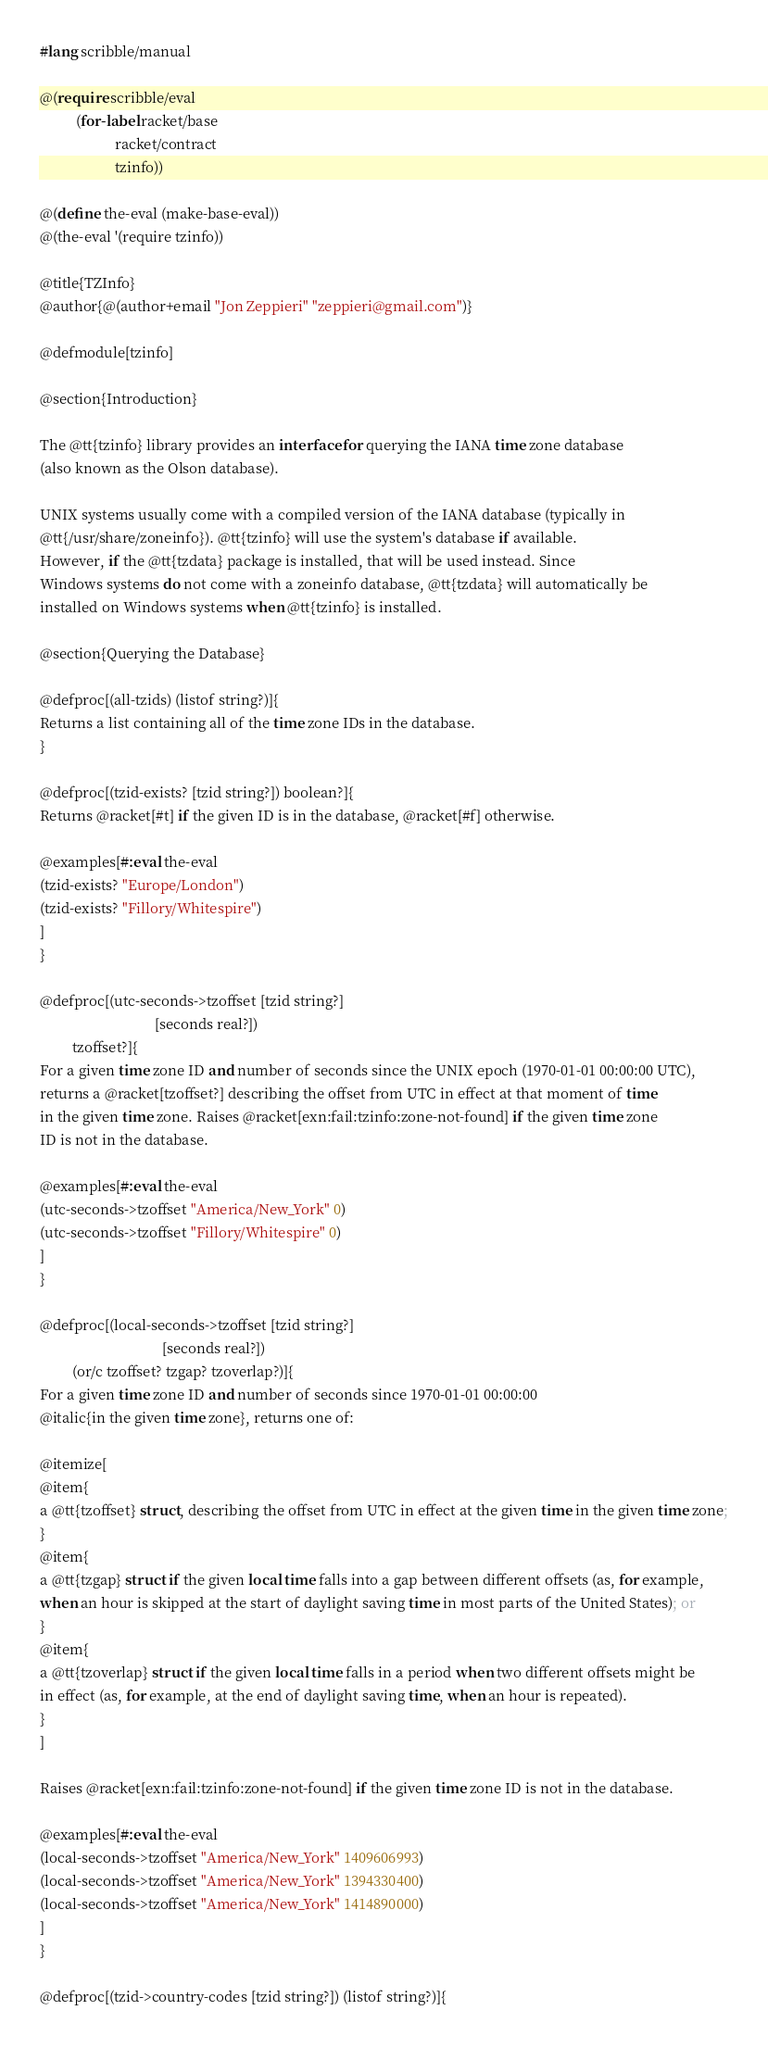<code> <loc_0><loc_0><loc_500><loc_500><_Racket_>#lang scribble/manual

@(require scribble/eval
          (for-label racket/base
                     racket/contract
                     tzinfo))

@(define the-eval (make-base-eval))
@(the-eval '(require tzinfo))

@title{TZInfo}
@author{@(author+email "Jon Zeppieri" "zeppieri@gmail.com")}

@defmodule[tzinfo]

@section{Introduction}

The @tt{tzinfo} library provides an interface for querying the IANA time zone database
(also known as the Olson database).

UNIX systems usually come with a compiled version of the IANA database (typically in
@tt{/usr/share/zoneinfo}). @tt{tzinfo} will use the system's database if available.
However, if the @tt{tzdata} package is installed, that will be used instead. Since
Windows systems do not come with a zoneinfo database, @tt{tzdata} will automatically be
installed on Windows systems when @tt{tzinfo} is installed.

@section{Querying the Database}

@defproc[(all-tzids) (listof string?)]{
Returns a list containing all of the time zone IDs in the database.
}

@defproc[(tzid-exists? [tzid string?]) boolean?]{
Returns @racket[#t] if the given ID is in the database, @racket[#f] otherwise.
        
@examples[#:eval the-eval
(tzid-exists? "Europe/London")
(tzid-exists? "Fillory/Whitespire")
]
}

@defproc[(utc-seconds->tzoffset [tzid string?]
                                [seconds real?])
         tzoffset?]{
For a given time zone ID and number of seconds since the UNIX epoch (1970-01-01 00:00:00 UTC),
returns a @racket[tzoffset?] describing the offset from UTC in effect at that moment of time
in the given time zone. Raises @racket[exn:fail:tzinfo:zone-not-found] if the given time zone
ID is not in the database.

@examples[#:eval the-eval
(utc-seconds->tzoffset "America/New_York" 0)
(utc-seconds->tzoffset "Fillory/Whitespire" 0)
]
}

@defproc[(local-seconds->tzoffset [tzid string?]
                                  [seconds real?])
         (or/c tzoffset? tzgap? tzoverlap?)]{
For a given time zone ID and number of seconds since 1970-01-01 00:00:00
@italic{in the given time zone}, returns one of:

@itemize[
@item{
a @tt{tzoffset} struct, describing the offset from UTC in effect at the given time in the given time zone;
}
@item{
a @tt{tzgap} struct if the given local time falls into a gap between different offsets (as, for example,
when an hour is skipped at the start of daylight saving time in most parts of the United States); or
}
@item{
a @tt{tzoverlap} struct if the given local time falls in a period when two different offsets might be
in effect (as, for example, at the end of daylight saving time, when an hour is repeated).
}
]

Raises @racket[exn:fail:tzinfo:zone-not-found] if the given time zone ID is not in the database.

@examples[#:eval the-eval
(local-seconds->tzoffset "America/New_York" 1409606993)
(local-seconds->tzoffset "America/New_York" 1394330400)
(local-seconds->tzoffset "America/New_York" 1414890000)
]
}

@defproc[(tzid->country-codes [tzid string?]) (listof string?)]{</code> 